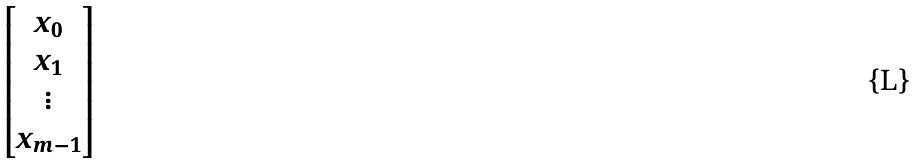<formula> <loc_0><loc_0><loc_500><loc_500>\begin{bmatrix} x _ { 0 } \\ x _ { 1 } \\ \vdots \\ x _ { m - 1 } \end{bmatrix}</formula> 